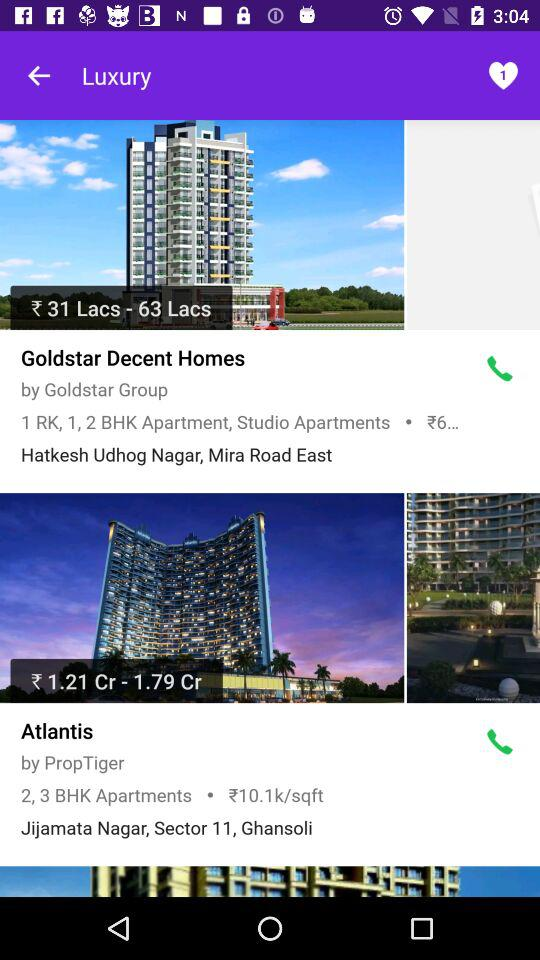What is the name of the construction group for "Goldstar Decent Homes"? The name of the construction group is Goldstar Group. 